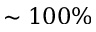<formula> <loc_0><loc_0><loc_500><loc_500>\sim 1 0 0 \%</formula> 